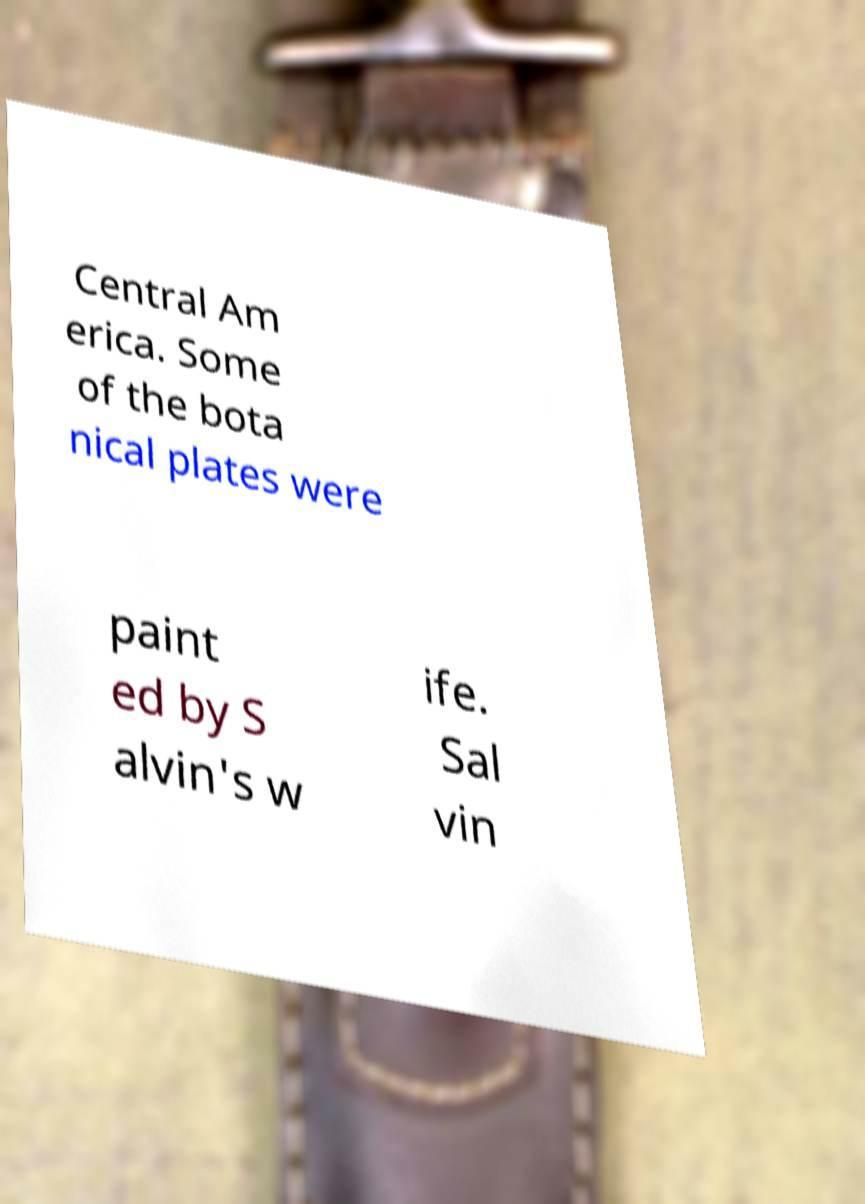There's text embedded in this image that I need extracted. Can you transcribe it verbatim? Central Am erica. Some of the bota nical plates were paint ed by S alvin's w ife. Sal vin 